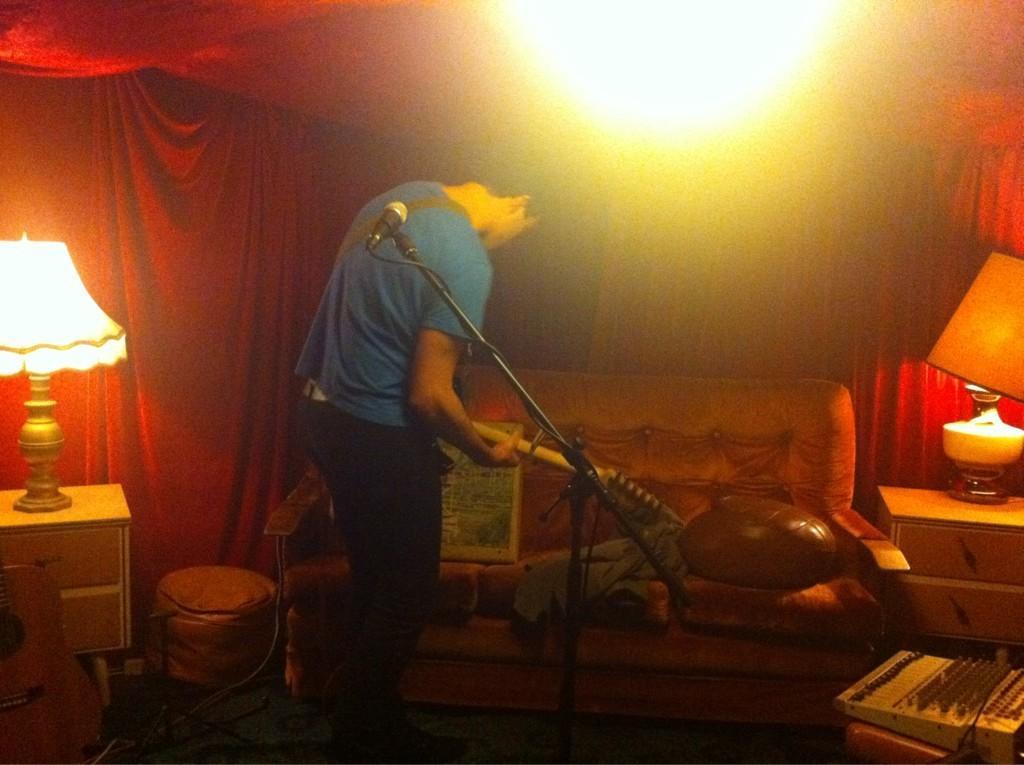Describe this image in one or two sentences. This image is clicked inside a tent. There is a man standing. He is holding a guitar in his hand. In front of him there is a couch. There are a few objects on the couch. Behind him there is a microphone to its stand. On the either sides of the image there are cabinets. There are table lamps on the cabinets. In the bottom right there is a audio mixer on a stool. At the top there is the light. 